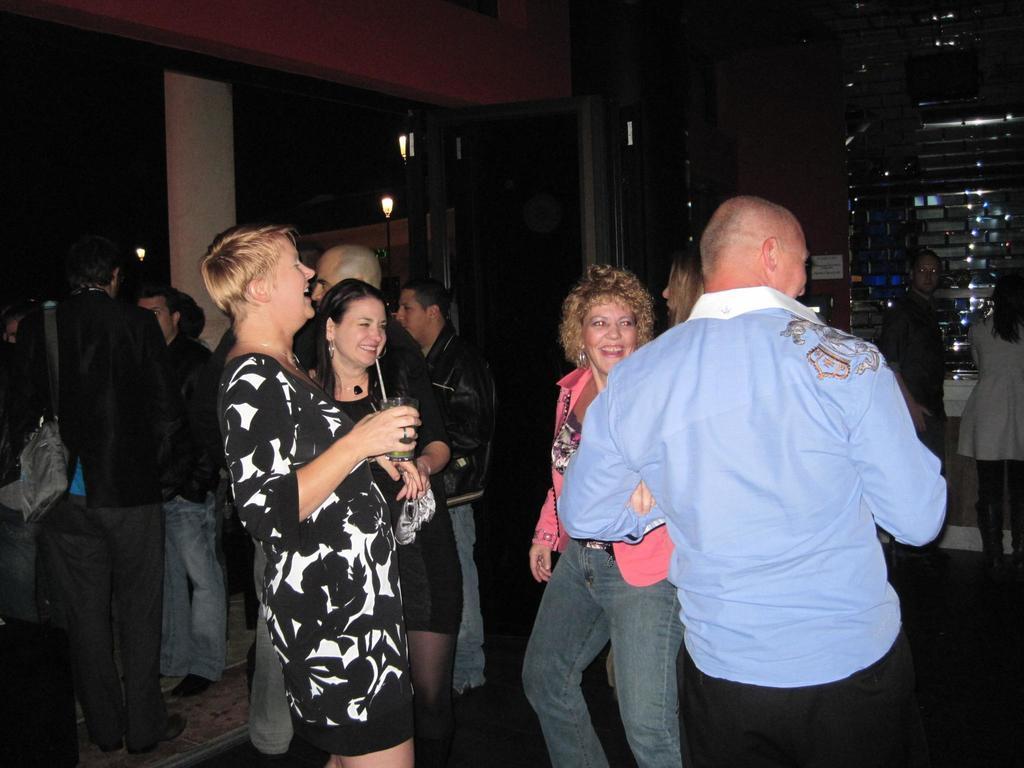Could you give a brief overview of what you see in this image? In this image, we can see a group of people standing. On the right side, we can see two people are standing in front of the metal grill. On the left side, we can see a pillar. In the background, we can see some street lights. At the top, we can see black color. 